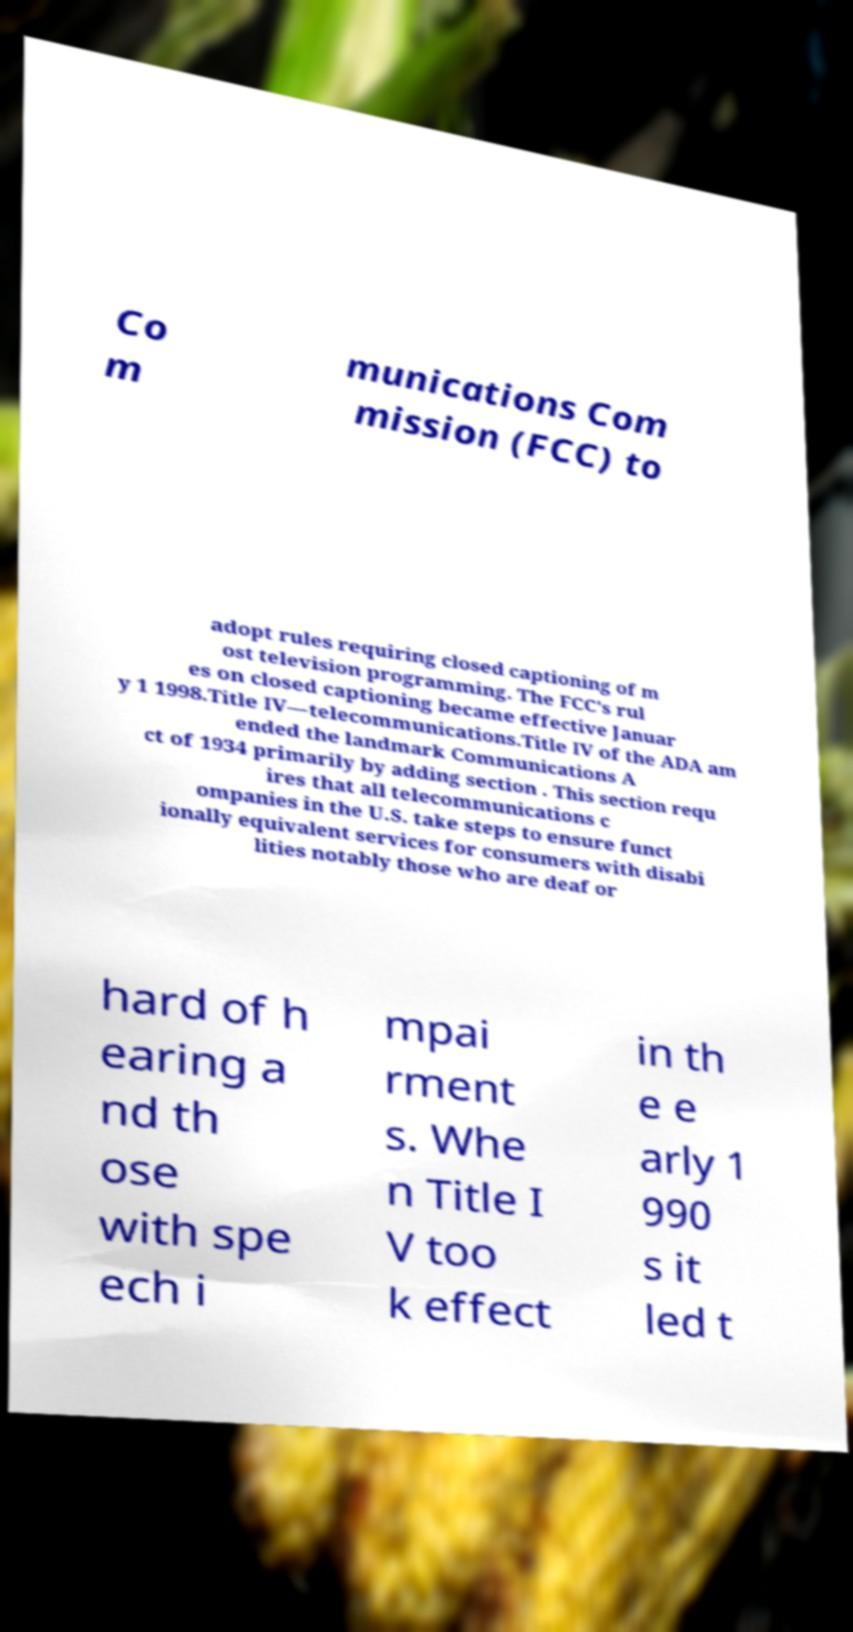Please identify and transcribe the text found in this image. Co m munications Com mission (FCC) to adopt rules requiring closed captioning of m ost television programming. The FCC's rul es on closed captioning became effective Januar y 1 1998.Title IV—telecommunications.Title IV of the ADA am ended the landmark Communications A ct of 1934 primarily by adding section . This section requ ires that all telecommunications c ompanies in the U.S. take steps to ensure funct ionally equivalent services for consumers with disabi lities notably those who are deaf or hard of h earing a nd th ose with spe ech i mpai rment s. Whe n Title I V too k effect in th e e arly 1 990 s it led t 